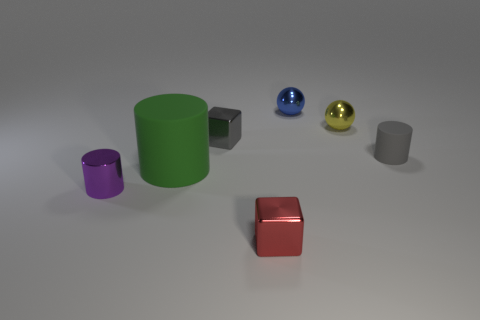Do the green matte thing on the left side of the gray cylinder and the small purple object have the same shape?
Give a very brief answer. Yes. How many objects are there?
Offer a terse response. 7. How many green spheres are the same size as the gray matte object?
Offer a very short reply. 0. What is the green cylinder made of?
Offer a very short reply. Rubber. There is a small matte thing; is its color the same as the metallic cube that is behind the tiny gray matte object?
Your answer should be very brief. Yes. Is there anything else that is the same size as the green thing?
Provide a short and direct response. No. What is the size of the cylinder that is both on the left side of the tiny red thing and behind the purple cylinder?
Your answer should be compact. Large. What is the shape of the green thing that is the same material as the tiny gray cylinder?
Your answer should be very brief. Cylinder. Do the tiny blue ball and the tiny cylinder to the left of the tiny gray cube have the same material?
Your response must be concise. Yes. There is a matte object to the right of the small red metal cube; are there any shiny cubes that are in front of it?
Keep it short and to the point. Yes. 